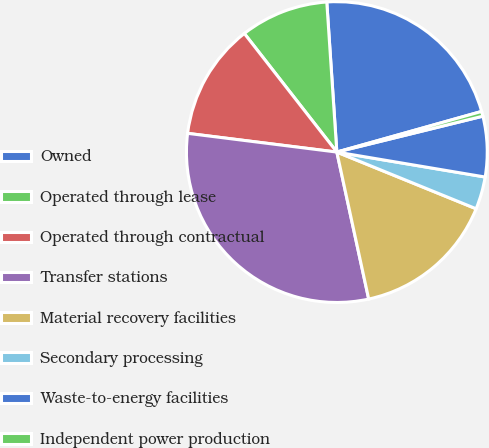Convert chart. <chart><loc_0><loc_0><loc_500><loc_500><pie_chart><fcel>Owned<fcel>Operated through lease<fcel>Operated through contractual<fcel>Transfer stations<fcel>Material recovery facilities<fcel>Secondary processing<fcel>Waste-to-energy facilities<fcel>Independent power production<nl><fcel>21.71%<fcel>9.48%<fcel>12.47%<fcel>30.39%<fcel>15.45%<fcel>3.5%<fcel>6.49%<fcel>0.52%<nl></chart> 